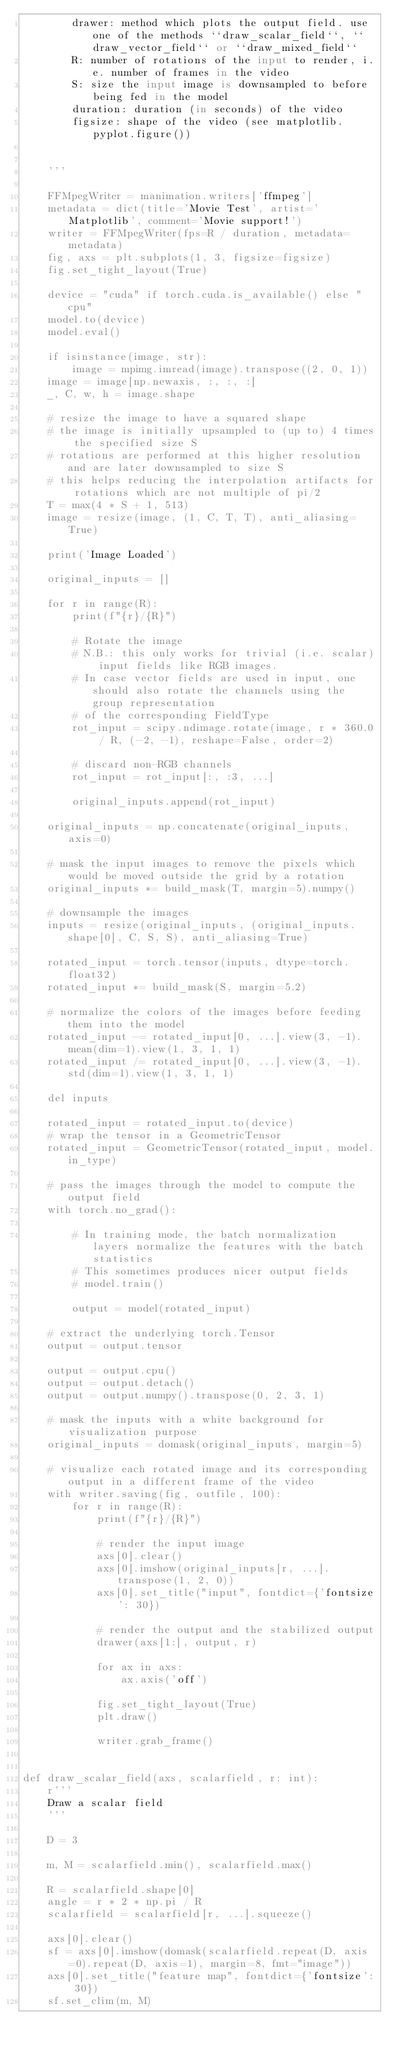<code> <loc_0><loc_0><loc_500><loc_500><_Python_>        drawer: method which plots the output field. use one of the methods ``draw_scalar_field``, ``draw_vector_field`` or ``draw_mixed_field``
        R: number of rotations of the input to render, i.e. number of frames in the video
        S: size the input image is downsampled to before being fed in the model
        duration: duration (in seconds) of the video
        figsize: shape of the video (see matplotlib.pyplot.figure())


    '''
    
    FFMpegWriter = manimation.writers['ffmpeg']
    metadata = dict(title='Movie Test', artist='Matplotlib', comment='Movie support!')
    writer = FFMpegWriter(fps=R / duration, metadata=metadata)
    fig, axs = plt.subplots(1, 3, figsize=figsize)
    fig.set_tight_layout(True)
    
    device = "cuda" if torch.cuda.is_available() else "cpu"
    model.to(device)
    model.eval()
    
    if isinstance(image, str):
        image = mpimg.imread(image).transpose((2, 0, 1))
    image = image[np.newaxis, :, :, :]
    _, C, w, h = image.shape
    
    # resize the image to have a squared shape
    # the image is initially upsampled to (up to) 4 times the specified size S
    # rotations are performed at this higher resolution and are later downsampled to size S
    # this helps reducing the interpolation artifacts for rotations which are not multiple of pi/2
    T = max(4 * S + 1, 513)
    image = resize(image, (1, C, T, T), anti_aliasing=True)
    
    print('Image Loaded')

    original_inputs = []
    
    for r in range(R):
        print(f"{r}/{R}")

        # Rotate the image
        # N.B.: this only works for trivial (i.e. scalar) input fields like RGB images.
        # In case vector fields are used in input, one should also rotate the channels using the group representation
        # of the corresponding FieldType
        rot_input = scipy.ndimage.rotate(image, r * 360.0 / R, (-2, -1), reshape=False, order=2)
        
        # discard non-RGB channels
        rot_input = rot_input[:, :3, ...]

        original_inputs.append(rot_input)

    original_inputs = np.concatenate(original_inputs, axis=0)
    
    # mask the input images to remove the pixels which would be moved outside the grid by a rotation
    original_inputs *= build_mask(T, margin=5).numpy()

    # downsample the images
    inputs = resize(original_inputs, (original_inputs.shape[0], C, S, S), anti_aliasing=True)
    
    rotated_input = torch.tensor(inputs, dtype=torch.float32)
    rotated_input *= build_mask(S, margin=5.2)
    
    # normalize the colors of the images before feeding them into the model
    rotated_input -= rotated_input[0, ...].view(3, -1).mean(dim=1).view(1, 3, 1, 1)
    rotated_input /= rotated_input[0, ...].view(3, -1).std(dim=1).view(1, 3, 1, 1)
    
    del inputs
    
    rotated_input = rotated_input.to(device)
    # wrap the tensor in a GeometricTensor
    rotated_input = GeometricTensor(rotated_input, model.in_type)

    # pass the images through the model to compute the output field
    with torch.no_grad():
        
        # In training mode, the batch normalization layers normalize the features with the batch statistics
        # This sometimes produces nicer output fields
        # model.train()
        
        output = model(rotated_input)

    # extract the underlying torch.Tensor
    output = output.tensor
    
    output = output.cpu()
    output = output.detach()
    output = output.numpy().transpose(0, 2, 3, 1)

    # mask the inputs with a white background for visualization purpose
    original_inputs = domask(original_inputs, margin=5)

    # visualize each rotated image and its corresponding output in a different frame of the video
    with writer.saving(fig, outfile, 100):
        for r in range(R):
            print(f"{r}/{R}")
            
            # render the input image
            axs[0].clear()
            axs[0].imshow(original_inputs[r, ...].transpose(1, 2, 0))
            axs[0].set_title("input", fontdict={'fontsize': 30})

            # render the output and the stabilized output
            drawer(axs[1:], output, r)
            
            for ax in axs:
                ax.axis('off')
            
            fig.set_tight_layout(True)
            plt.draw()
            
            writer.grab_frame()


def draw_scalar_field(axs, scalarfield, r: int):
    r'''
    Draw a scalar field
    '''
    
    D = 3
    
    m, M = scalarfield.min(), scalarfield.max()
    
    R = scalarfield.shape[0]
    angle = r * 2 * np.pi / R
    scalarfield = scalarfield[r, ...].squeeze()
    
    axs[0].clear()
    sf = axs[0].imshow(domask(scalarfield.repeat(D, axis=0).repeat(D, axis=1), margin=8, fmt="image"))
    axs[0].set_title("feature map", fontdict={'fontsize': 30})
    sf.set_clim(m, M)
    </code> 